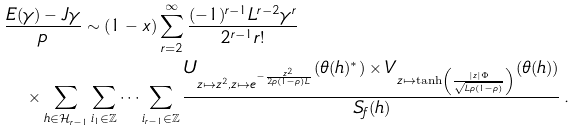Convert formula to latex. <formula><loc_0><loc_0><loc_500><loc_500>& \frac { E ( \gamma ) - J \gamma } { p } \sim ( 1 - x ) \sum _ { r = 2 } ^ { \infty } \frac { ( - 1 ) ^ { r - 1 } L ^ { r - 2 } \gamma ^ { r } } { 2 ^ { r - 1 } r ! } \\ & \quad \times \sum _ { h \in \mathcal { H } _ { r - 1 } } \sum _ { i _ { 1 } \in \mathbb { Z } } \dots \sum _ { i _ { r - 1 } \in \mathbb { Z } } \frac { U _ { z \mapsto z ^ { 2 } , z \mapsto e ^ { - \frac { z ^ { 2 } } { 2 \rho ( 1 - \rho ) L } } } ( \theta ( h ) ^ { * } ) \times V _ { z \mapsto \tanh \left ( \frac { | z | \Phi } { \sqrt { L \rho ( 1 - \rho ) } } \right ) } ( \theta ( h ) ) } { S _ { f } ( h ) } \, .</formula> 